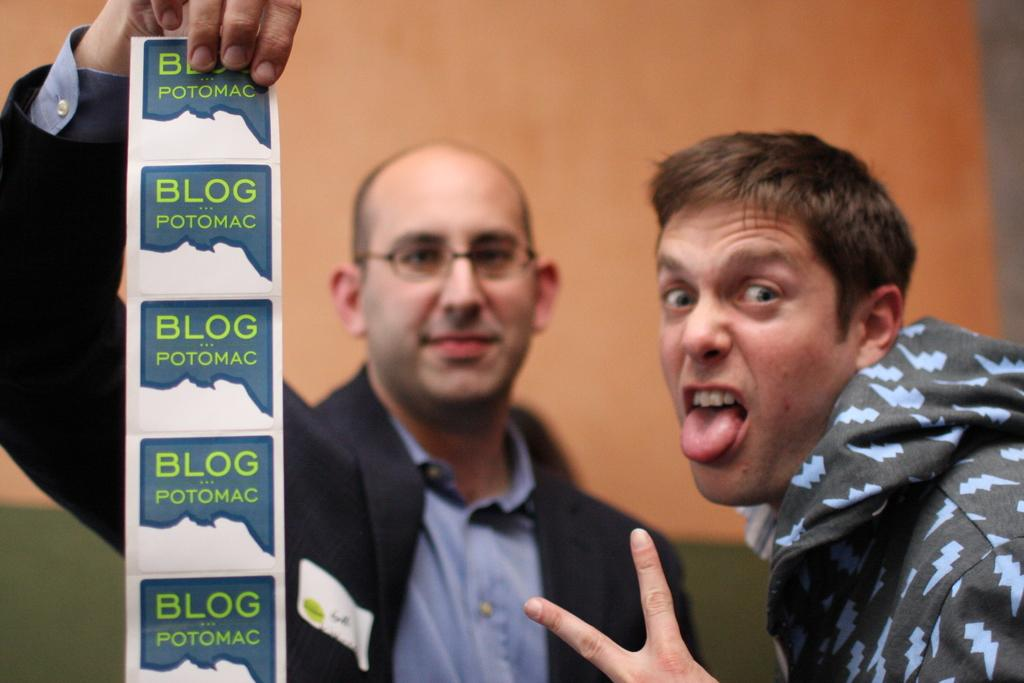What is the person holding in the image? There is a person holding a paper in the image. Can you describe the other person in the image? There is another person beside the first person. What can be seen in the background of the image? There is a wall visible in the background of the image. What type of plastic material is covering the table in the image? There is no table present in the image, so it is not possible to determine if there is any plastic material covering it. 